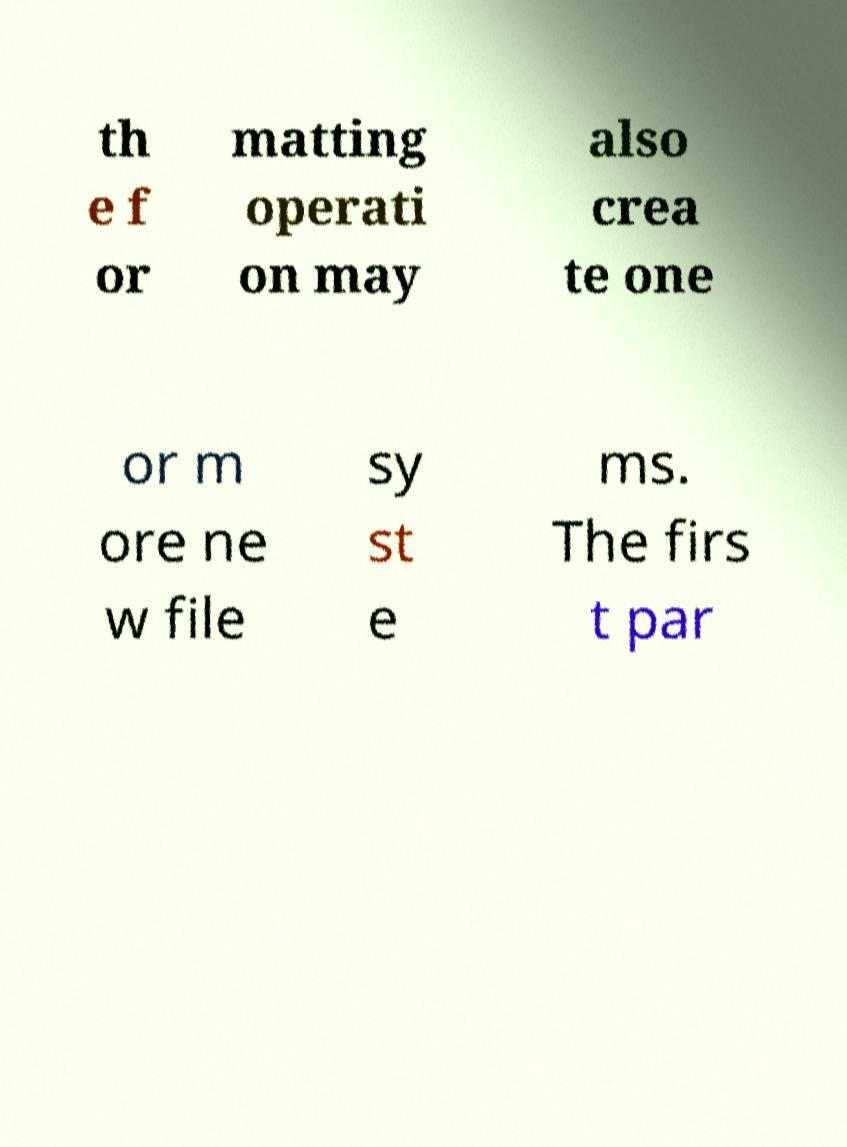There's text embedded in this image that I need extracted. Can you transcribe it verbatim? th e f or matting operati on may also crea te one or m ore ne w file sy st e ms. The firs t par 